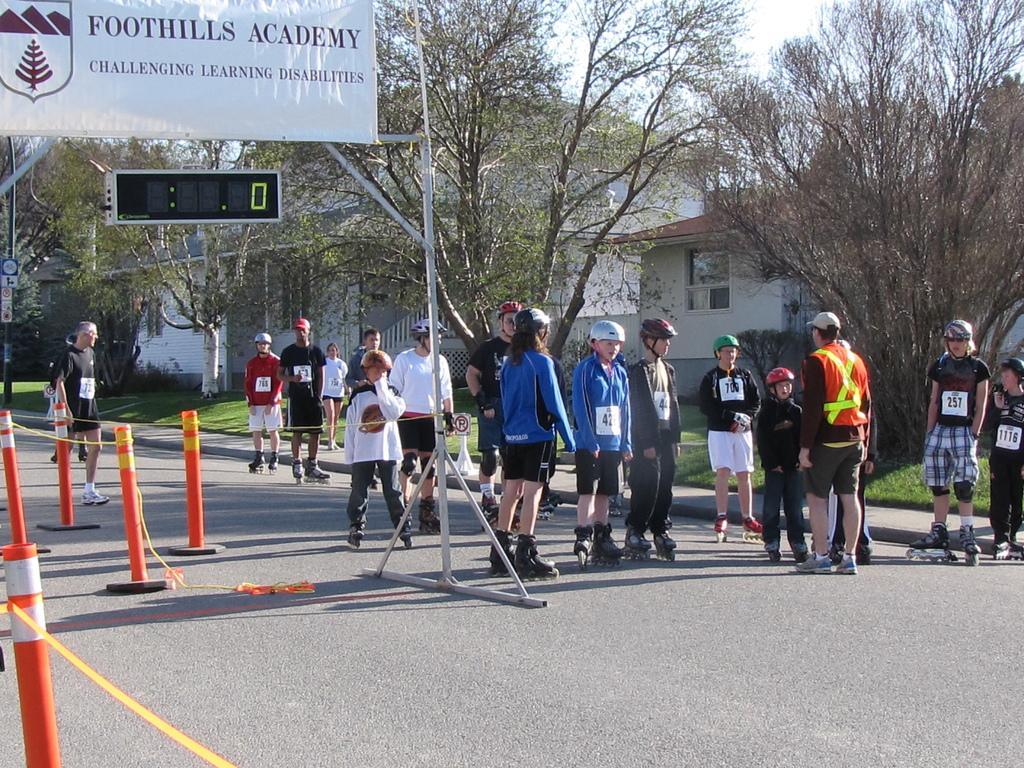Could you give a brief overview of what you see in this image? This picture shows few people standing. They wore skates and helmet on their heads and we see trees, houses and we see a digital timer and we see a banner to it and a cloudy sky and we see grass on the ground, 